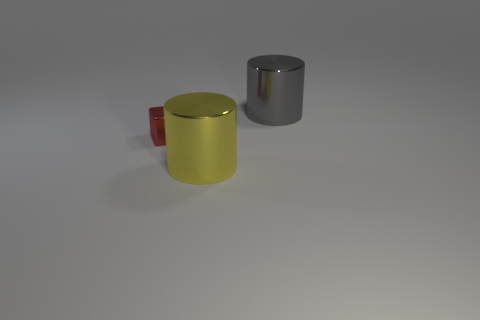How many other objects are there of the same size as the yellow object?
Your answer should be very brief. 1. What number of big things are red cubes or gray metallic cylinders?
Offer a terse response. 1. Are there more tiny things that are to the right of the gray metallic cylinder than big shiny cylinders that are in front of the block?
Provide a succinct answer. No. There is a object right of the yellow cylinder; does it have the same color as the tiny shiny cube?
Your answer should be compact. No. Is there any other thing of the same color as the small block?
Provide a short and direct response. No. Is the number of metallic cylinders that are left of the cube greater than the number of big shiny objects?
Offer a terse response. No. Is the gray metal thing the same size as the yellow thing?
Your answer should be very brief. Yes. What material is the other large object that is the same shape as the gray shiny object?
Your answer should be compact. Metal. What number of cyan objects are either tiny blocks or shiny cylinders?
Keep it short and to the point. 0. What is the large object behind the big yellow cylinder made of?
Keep it short and to the point. Metal. 